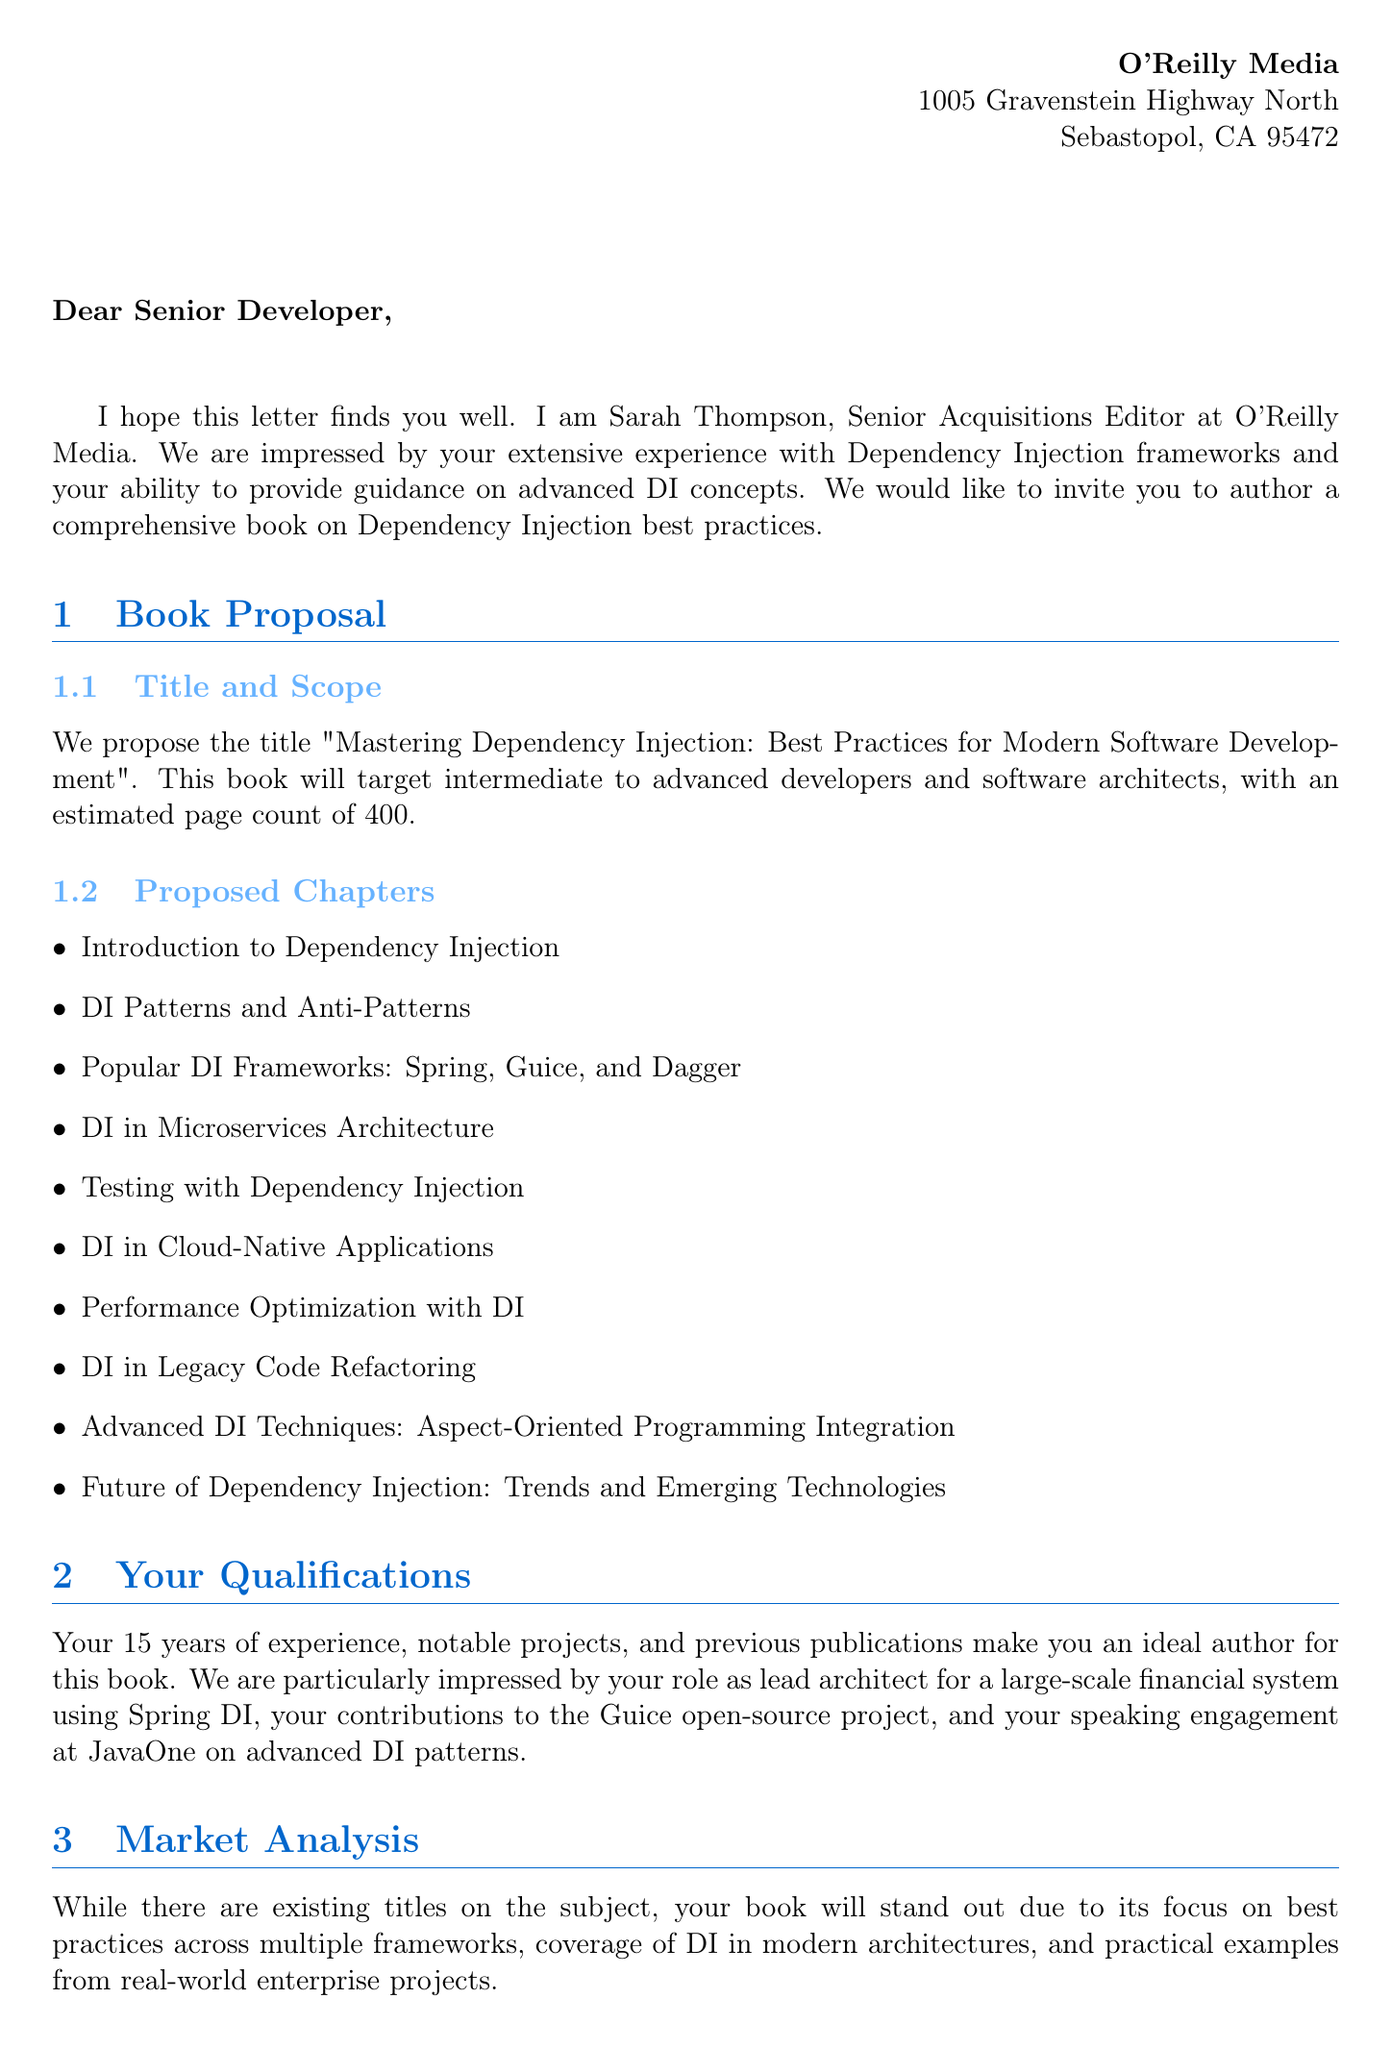What is the name of the publisher? The letter specifies that the publisher is O'Reilly Media.
Answer: O'Reilly Media Who is the contact person at the publisher? According to the document, the contact person is Sarah Thompson.
Answer: Sarah Thompson What is the proposed title of the book? The title proposed in the letter is "Mastering Dependency Injection: Best Practices for Modern Software Development".
Answer: Mastering Dependency Injection: Best Practices for Modern Software Development What is the estimated page count for the book? The document mentions that the estimated page count is 400.
Answer: 400 What is the advance payment offered to the author? The advance payment mentioned in the document is $10,000.
Answer: $10,000 What is one of the unique selling points of the book? The document states it focuses on best practices across multiple frameworks as a unique selling point.
Answer: Focus on best practices across multiple frameworks When is the first draft due? The letter specifies that the first draft is due on February 1, 2024.
Answer: February 1, 2024 Which programming conference did the author speak at? The document indicates the author spoke at the JavaOne conference.
Answer: JavaOne What is one of the additional requests from the publisher? One additional request from the publisher is to make code samples available on GitHub.
Answer: Code samples to be available on GitHub 